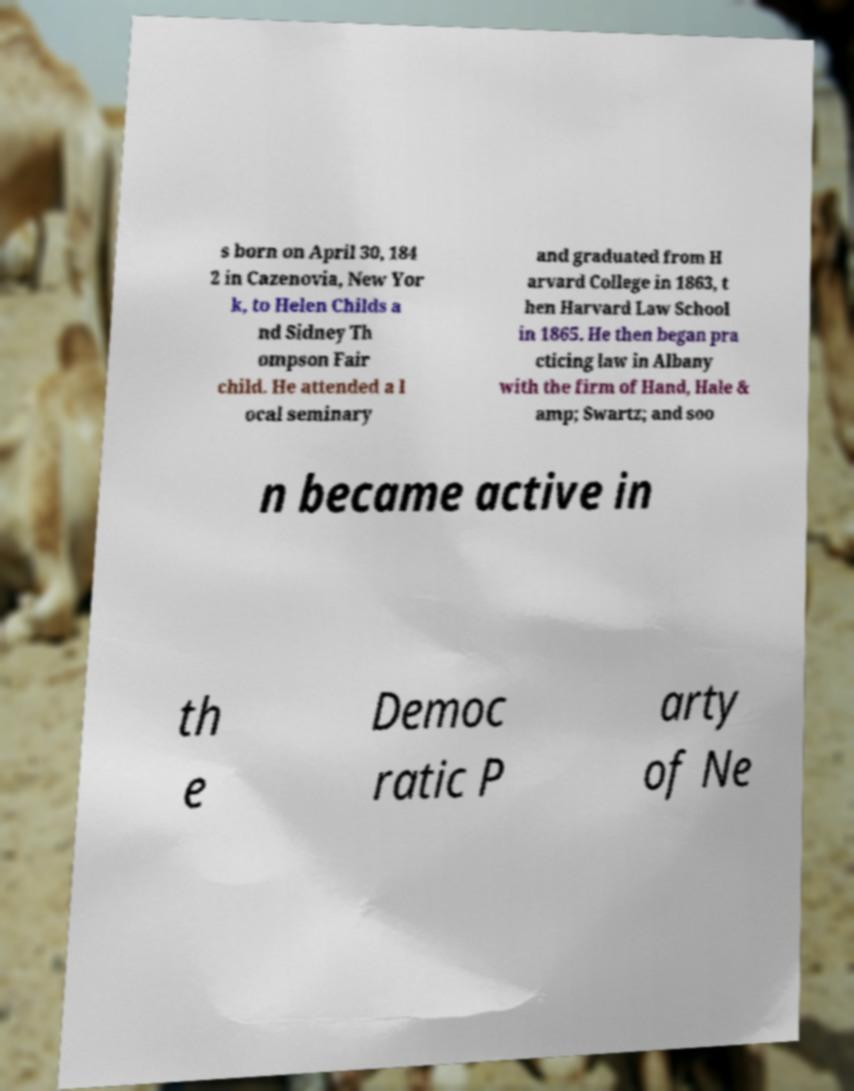Please read and relay the text visible in this image. What does it say? s born on April 30, 184 2 in Cazenovia, New Yor k, to Helen Childs a nd Sidney Th ompson Fair child. He attended a l ocal seminary and graduated from H arvard College in 1863, t hen Harvard Law School in 1865. He then began pra cticing law in Albany with the firm of Hand, Hale & amp; Swartz; and soo n became active in th e Democ ratic P arty of Ne 